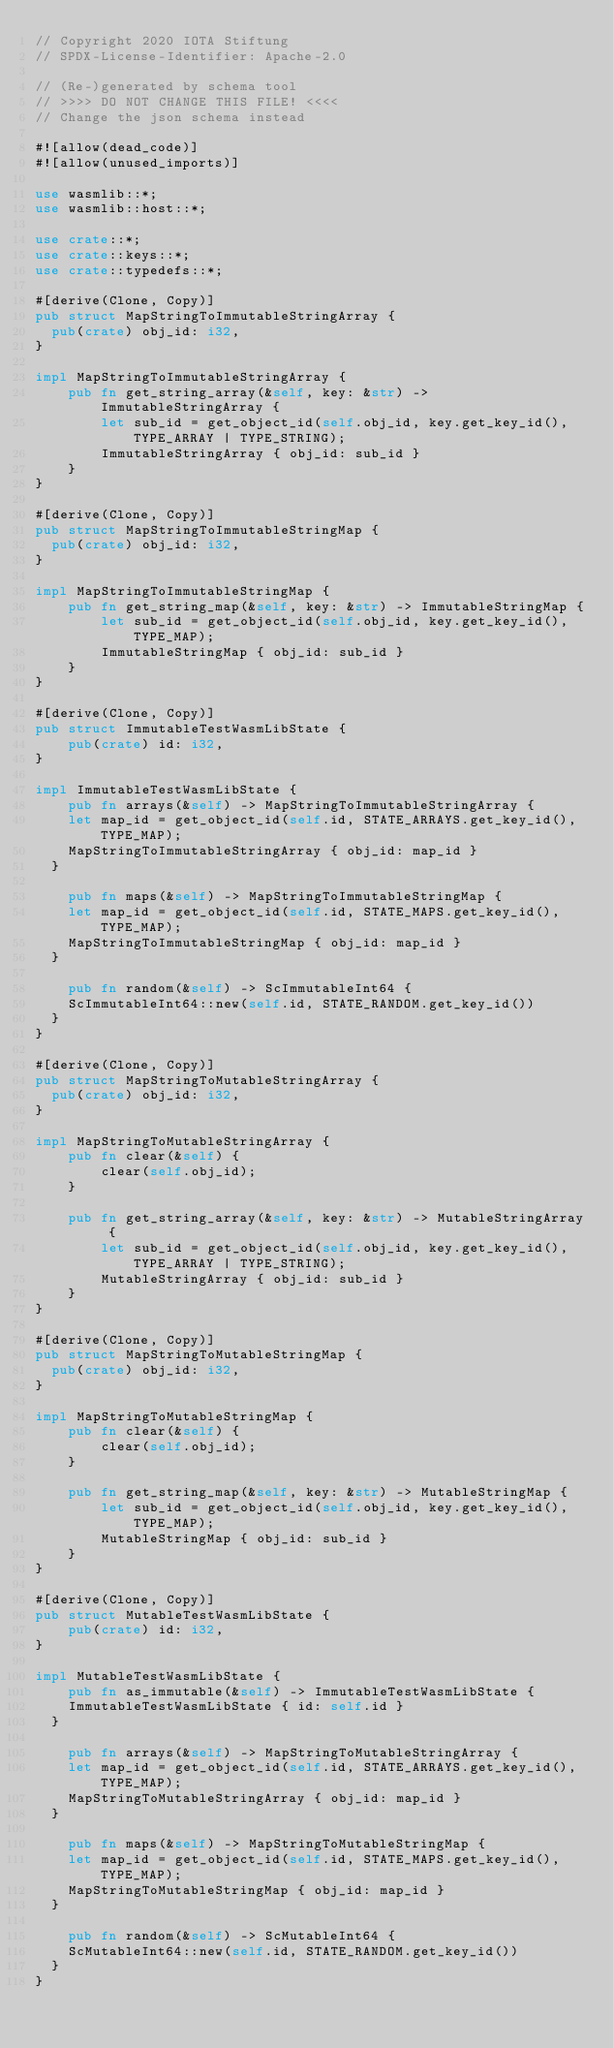<code> <loc_0><loc_0><loc_500><loc_500><_Rust_>// Copyright 2020 IOTA Stiftung
// SPDX-License-Identifier: Apache-2.0

// (Re-)generated by schema tool
// >>>> DO NOT CHANGE THIS FILE! <<<<
// Change the json schema instead

#![allow(dead_code)]
#![allow(unused_imports)]

use wasmlib::*;
use wasmlib::host::*;

use crate::*;
use crate::keys::*;
use crate::typedefs::*;

#[derive(Clone, Copy)]
pub struct MapStringToImmutableStringArray {
	pub(crate) obj_id: i32,
}

impl MapStringToImmutableStringArray {
    pub fn get_string_array(&self, key: &str) -> ImmutableStringArray {
        let sub_id = get_object_id(self.obj_id, key.get_key_id(), TYPE_ARRAY | TYPE_STRING);
        ImmutableStringArray { obj_id: sub_id }
    }
}

#[derive(Clone, Copy)]
pub struct MapStringToImmutableStringMap {
	pub(crate) obj_id: i32,
}

impl MapStringToImmutableStringMap {
    pub fn get_string_map(&self, key: &str) -> ImmutableStringMap {
        let sub_id = get_object_id(self.obj_id, key.get_key_id(), TYPE_MAP);
        ImmutableStringMap { obj_id: sub_id }
    }
}

#[derive(Clone, Copy)]
pub struct ImmutableTestWasmLibState {
    pub(crate) id: i32,
}

impl ImmutableTestWasmLibState {
    pub fn arrays(&self) -> MapStringToImmutableStringArray {
		let map_id = get_object_id(self.id, STATE_ARRAYS.get_key_id(), TYPE_MAP);
		MapStringToImmutableStringArray { obj_id: map_id }
	}

    pub fn maps(&self) -> MapStringToImmutableStringMap {
		let map_id = get_object_id(self.id, STATE_MAPS.get_key_id(), TYPE_MAP);
		MapStringToImmutableStringMap { obj_id: map_id }
	}

    pub fn random(&self) -> ScImmutableInt64 {
		ScImmutableInt64::new(self.id, STATE_RANDOM.get_key_id())
	}
}

#[derive(Clone, Copy)]
pub struct MapStringToMutableStringArray {
	pub(crate) obj_id: i32,
}

impl MapStringToMutableStringArray {
    pub fn clear(&self) {
        clear(self.obj_id);
    }

    pub fn get_string_array(&self, key: &str) -> MutableStringArray {
        let sub_id = get_object_id(self.obj_id, key.get_key_id(), TYPE_ARRAY | TYPE_STRING);
        MutableStringArray { obj_id: sub_id }
    }
}

#[derive(Clone, Copy)]
pub struct MapStringToMutableStringMap {
	pub(crate) obj_id: i32,
}

impl MapStringToMutableStringMap {
    pub fn clear(&self) {
        clear(self.obj_id);
    }

    pub fn get_string_map(&self, key: &str) -> MutableStringMap {
        let sub_id = get_object_id(self.obj_id, key.get_key_id(), TYPE_MAP);
        MutableStringMap { obj_id: sub_id }
    }
}

#[derive(Clone, Copy)]
pub struct MutableTestWasmLibState {
    pub(crate) id: i32,
}

impl MutableTestWasmLibState {
    pub fn as_immutable(&self) -> ImmutableTestWasmLibState {
		ImmutableTestWasmLibState { id: self.id }
	}

    pub fn arrays(&self) -> MapStringToMutableStringArray {
		let map_id = get_object_id(self.id, STATE_ARRAYS.get_key_id(), TYPE_MAP);
		MapStringToMutableStringArray { obj_id: map_id }
	}

    pub fn maps(&self) -> MapStringToMutableStringMap {
		let map_id = get_object_id(self.id, STATE_MAPS.get_key_id(), TYPE_MAP);
		MapStringToMutableStringMap { obj_id: map_id }
	}

    pub fn random(&self) -> ScMutableInt64 {
		ScMutableInt64::new(self.id, STATE_RANDOM.get_key_id())
	}
}
</code> 